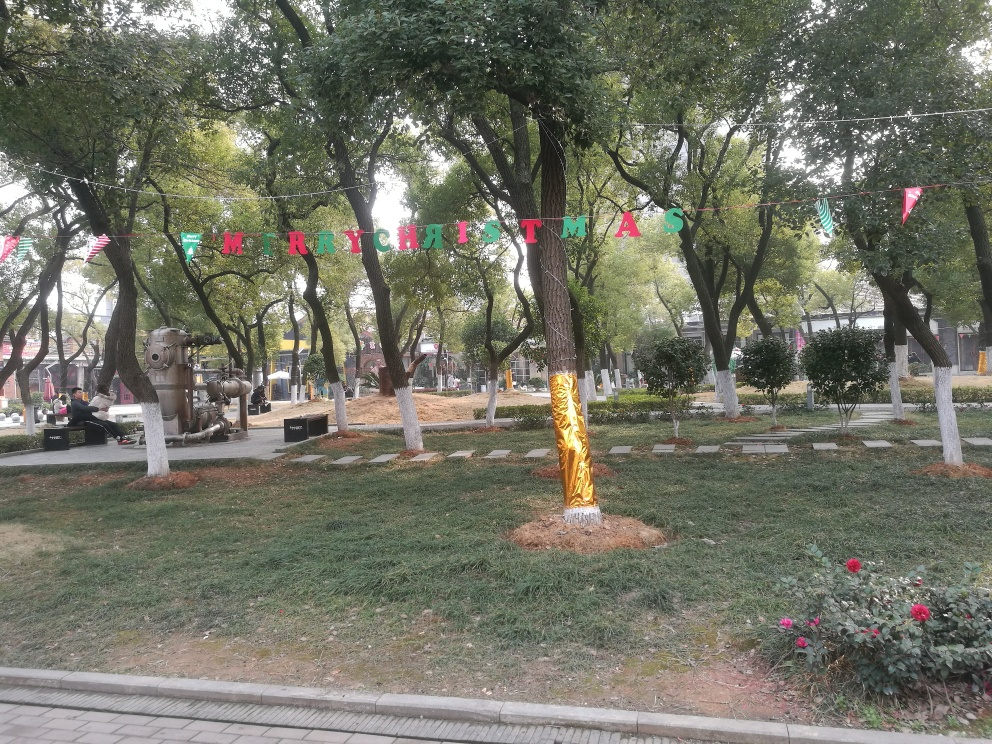What is the subject of the image?
A. The subject is a river.
B. The subject is trees and a lawn.
C. The subject is a cityscape.
Answer with the option's letter from the given choices directly.
 B. 